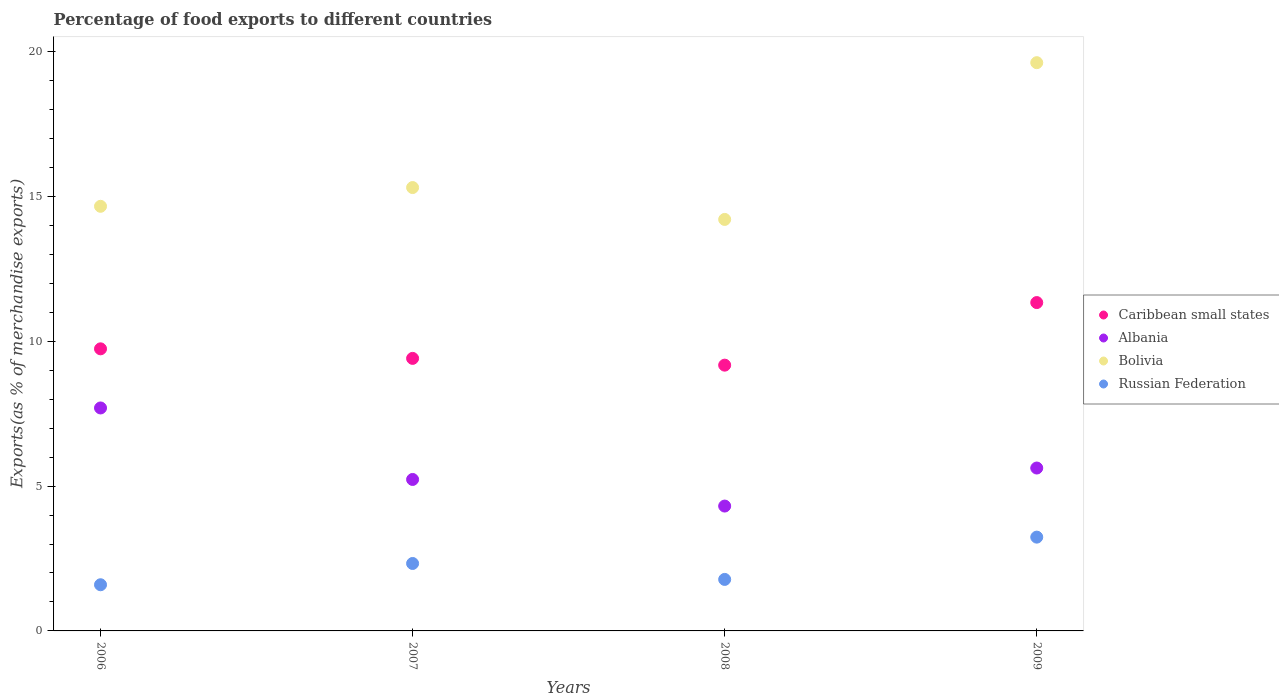How many different coloured dotlines are there?
Your response must be concise. 4. Is the number of dotlines equal to the number of legend labels?
Provide a short and direct response. Yes. What is the percentage of exports to different countries in Albania in 2007?
Provide a succinct answer. 5.23. Across all years, what is the maximum percentage of exports to different countries in Bolivia?
Your answer should be compact. 19.62. Across all years, what is the minimum percentage of exports to different countries in Russian Federation?
Make the answer very short. 1.59. What is the total percentage of exports to different countries in Russian Federation in the graph?
Make the answer very short. 8.94. What is the difference between the percentage of exports to different countries in Caribbean small states in 2007 and that in 2008?
Your answer should be very brief. 0.23. What is the difference between the percentage of exports to different countries in Caribbean small states in 2009 and the percentage of exports to different countries in Bolivia in 2007?
Provide a succinct answer. -3.97. What is the average percentage of exports to different countries in Bolivia per year?
Offer a very short reply. 15.95. In the year 2007, what is the difference between the percentage of exports to different countries in Bolivia and percentage of exports to different countries in Albania?
Your response must be concise. 10.08. What is the ratio of the percentage of exports to different countries in Bolivia in 2006 to that in 2009?
Provide a succinct answer. 0.75. Is the percentage of exports to different countries in Bolivia in 2006 less than that in 2009?
Your answer should be very brief. Yes. What is the difference between the highest and the second highest percentage of exports to different countries in Bolivia?
Provide a short and direct response. 4.31. What is the difference between the highest and the lowest percentage of exports to different countries in Albania?
Keep it short and to the point. 3.39. Is the sum of the percentage of exports to different countries in Caribbean small states in 2008 and 2009 greater than the maximum percentage of exports to different countries in Bolivia across all years?
Ensure brevity in your answer.  Yes. Is it the case that in every year, the sum of the percentage of exports to different countries in Caribbean small states and percentage of exports to different countries in Albania  is greater than the sum of percentage of exports to different countries in Russian Federation and percentage of exports to different countries in Bolivia?
Keep it short and to the point. Yes. Is the percentage of exports to different countries in Albania strictly greater than the percentage of exports to different countries in Caribbean small states over the years?
Provide a short and direct response. No. What is the difference between two consecutive major ticks on the Y-axis?
Make the answer very short. 5. Does the graph contain grids?
Your answer should be compact. No. Where does the legend appear in the graph?
Offer a very short reply. Center right. What is the title of the graph?
Ensure brevity in your answer.  Percentage of food exports to different countries. Does "Latin America(all income levels)" appear as one of the legend labels in the graph?
Make the answer very short. No. What is the label or title of the Y-axis?
Offer a very short reply. Exports(as % of merchandise exports). What is the Exports(as % of merchandise exports) in Caribbean small states in 2006?
Make the answer very short. 9.74. What is the Exports(as % of merchandise exports) of Albania in 2006?
Provide a succinct answer. 7.7. What is the Exports(as % of merchandise exports) of Bolivia in 2006?
Give a very brief answer. 14.66. What is the Exports(as % of merchandise exports) of Russian Federation in 2006?
Make the answer very short. 1.59. What is the Exports(as % of merchandise exports) of Caribbean small states in 2007?
Keep it short and to the point. 9.41. What is the Exports(as % of merchandise exports) of Albania in 2007?
Your response must be concise. 5.23. What is the Exports(as % of merchandise exports) in Bolivia in 2007?
Give a very brief answer. 15.31. What is the Exports(as % of merchandise exports) in Russian Federation in 2007?
Provide a succinct answer. 2.33. What is the Exports(as % of merchandise exports) of Caribbean small states in 2008?
Offer a very short reply. 9.18. What is the Exports(as % of merchandise exports) of Albania in 2008?
Keep it short and to the point. 4.31. What is the Exports(as % of merchandise exports) in Bolivia in 2008?
Your answer should be very brief. 14.21. What is the Exports(as % of merchandise exports) in Russian Federation in 2008?
Offer a terse response. 1.78. What is the Exports(as % of merchandise exports) in Caribbean small states in 2009?
Make the answer very short. 11.34. What is the Exports(as % of merchandise exports) of Albania in 2009?
Offer a very short reply. 5.62. What is the Exports(as % of merchandise exports) of Bolivia in 2009?
Provide a short and direct response. 19.62. What is the Exports(as % of merchandise exports) of Russian Federation in 2009?
Your answer should be very brief. 3.24. Across all years, what is the maximum Exports(as % of merchandise exports) in Caribbean small states?
Provide a succinct answer. 11.34. Across all years, what is the maximum Exports(as % of merchandise exports) in Albania?
Give a very brief answer. 7.7. Across all years, what is the maximum Exports(as % of merchandise exports) in Bolivia?
Keep it short and to the point. 19.62. Across all years, what is the maximum Exports(as % of merchandise exports) in Russian Federation?
Your answer should be compact. 3.24. Across all years, what is the minimum Exports(as % of merchandise exports) of Caribbean small states?
Provide a short and direct response. 9.18. Across all years, what is the minimum Exports(as % of merchandise exports) in Albania?
Your response must be concise. 4.31. Across all years, what is the minimum Exports(as % of merchandise exports) in Bolivia?
Offer a very short reply. 14.21. Across all years, what is the minimum Exports(as % of merchandise exports) of Russian Federation?
Offer a very short reply. 1.59. What is the total Exports(as % of merchandise exports) in Caribbean small states in the graph?
Provide a short and direct response. 39.66. What is the total Exports(as % of merchandise exports) in Albania in the graph?
Your answer should be very brief. 22.86. What is the total Exports(as % of merchandise exports) of Bolivia in the graph?
Provide a succinct answer. 63.8. What is the total Exports(as % of merchandise exports) of Russian Federation in the graph?
Your answer should be very brief. 8.94. What is the difference between the Exports(as % of merchandise exports) of Caribbean small states in 2006 and that in 2007?
Provide a succinct answer. 0.33. What is the difference between the Exports(as % of merchandise exports) of Albania in 2006 and that in 2007?
Keep it short and to the point. 2.47. What is the difference between the Exports(as % of merchandise exports) in Bolivia in 2006 and that in 2007?
Your answer should be very brief. -0.65. What is the difference between the Exports(as % of merchandise exports) in Russian Federation in 2006 and that in 2007?
Ensure brevity in your answer.  -0.73. What is the difference between the Exports(as % of merchandise exports) in Caribbean small states in 2006 and that in 2008?
Provide a succinct answer. 0.56. What is the difference between the Exports(as % of merchandise exports) in Albania in 2006 and that in 2008?
Give a very brief answer. 3.39. What is the difference between the Exports(as % of merchandise exports) in Bolivia in 2006 and that in 2008?
Make the answer very short. 0.45. What is the difference between the Exports(as % of merchandise exports) of Russian Federation in 2006 and that in 2008?
Offer a very short reply. -0.18. What is the difference between the Exports(as % of merchandise exports) in Caribbean small states in 2006 and that in 2009?
Provide a succinct answer. -1.6. What is the difference between the Exports(as % of merchandise exports) in Albania in 2006 and that in 2009?
Your answer should be compact. 2.07. What is the difference between the Exports(as % of merchandise exports) in Bolivia in 2006 and that in 2009?
Provide a short and direct response. -4.96. What is the difference between the Exports(as % of merchandise exports) of Russian Federation in 2006 and that in 2009?
Provide a short and direct response. -1.64. What is the difference between the Exports(as % of merchandise exports) in Caribbean small states in 2007 and that in 2008?
Make the answer very short. 0.23. What is the difference between the Exports(as % of merchandise exports) in Albania in 2007 and that in 2008?
Provide a short and direct response. 0.92. What is the difference between the Exports(as % of merchandise exports) of Bolivia in 2007 and that in 2008?
Your response must be concise. 1.1. What is the difference between the Exports(as % of merchandise exports) in Russian Federation in 2007 and that in 2008?
Give a very brief answer. 0.55. What is the difference between the Exports(as % of merchandise exports) of Caribbean small states in 2007 and that in 2009?
Provide a succinct answer. -1.93. What is the difference between the Exports(as % of merchandise exports) of Albania in 2007 and that in 2009?
Your answer should be very brief. -0.39. What is the difference between the Exports(as % of merchandise exports) of Bolivia in 2007 and that in 2009?
Ensure brevity in your answer.  -4.31. What is the difference between the Exports(as % of merchandise exports) of Russian Federation in 2007 and that in 2009?
Give a very brief answer. -0.91. What is the difference between the Exports(as % of merchandise exports) in Caribbean small states in 2008 and that in 2009?
Make the answer very short. -2.16. What is the difference between the Exports(as % of merchandise exports) in Albania in 2008 and that in 2009?
Give a very brief answer. -1.31. What is the difference between the Exports(as % of merchandise exports) in Bolivia in 2008 and that in 2009?
Your answer should be compact. -5.41. What is the difference between the Exports(as % of merchandise exports) of Russian Federation in 2008 and that in 2009?
Your response must be concise. -1.46. What is the difference between the Exports(as % of merchandise exports) in Caribbean small states in 2006 and the Exports(as % of merchandise exports) in Albania in 2007?
Keep it short and to the point. 4.51. What is the difference between the Exports(as % of merchandise exports) in Caribbean small states in 2006 and the Exports(as % of merchandise exports) in Bolivia in 2007?
Provide a short and direct response. -5.57. What is the difference between the Exports(as % of merchandise exports) of Caribbean small states in 2006 and the Exports(as % of merchandise exports) of Russian Federation in 2007?
Give a very brief answer. 7.41. What is the difference between the Exports(as % of merchandise exports) of Albania in 2006 and the Exports(as % of merchandise exports) of Bolivia in 2007?
Your answer should be very brief. -7.61. What is the difference between the Exports(as % of merchandise exports) of Albania in 2006 and the Exports(as % of merchandise exports) of Russian Federation in 2007?
Make the answer very short. 5.37. What is the difference between the Exports(as % of merchandise exports) of Bolivia in 2006 and the Exports(as % of merchandise exports) of Russian Federation in 2007?
Ensure brevity in your answer.  12.33. What is the difference between the Exports(as % of merchandise exports) of Caribbean small states in 2006 and the Exports(as % of merchandise exports) of Albania in 2008?
Keep it short and to the point. 5.43. What is the difference between the Exports(as % of merchandise exports) in Caribbean small states in 2006 and the Exports(as % of merchandise exports) in Bolivia in 2008?
Offer a terse response. -4.47. What is the difference between the Exports(as % of merchandise exports) of Caribbean small states in 2006 and the Exports(as % of merchandise exports) of Russian Federation in 2008?
Provide a short and direct response. 7.96. What is the difference between the Exports(as % of merchandise exports) of Albania in 2006 and the Exports(as % of merchandise exports) of Bolivia in 2008?
Offer a very short reply. -6.51. What is the difference between the Exports(as % of merchandise exports) of Albania in 2006 and the Exports(as % of merchandise exports) of Russian Federation in 2008?
Provide a succinct answer. 5.92. What is the difference between the Exports(as % of merchandise exports) in Bolivia in 2006 and the Exports(as % of merchandise exports) in Russian Federation in 2008?
Ensure brevity in your answer.  12.88. What is the difference between the Exports(as % of merchandise exports) in Caribbean small states in 2006 and the Exports(as % of merchandise exports) in Albania in 2009?
Keep it short and to the point. 4.12. What is the difference between the Exports(as % of merchandise exports) in Caribbean small states in 2006 and the Exports(as % of merchandise exports) in Bolivia in 2009?
Offer a very short reply. -9.88. What is the difference between the Exports(as % of merchandise exports) of Caribbean small states in 2006 and the Exports(as % of merchandise exports) of Russian Federation in 2009?
Ensure brevity in your answer.  6.5. What is the difference between the Exports(as % of merchandise exports) of Albania in 2006 and the Exports(as % of merchandise exports) of Bolivia in 2009?
Your answer should be compact. -11.92. What is the difference between the Exports(as % of merchandise exports) of Albania in 2006 and the Exports(as % of merchandise exports) of Russian Federation in 2009?
Provide a short and direct response. 4.46. What is the difference between the Exports(as % of merchandise exports) in Bolivia in 2006 and the Exports(as % of merchandise exports) in Russian Federation in 2009?
Your answer should be very brief. 11.42. What is the difference between the Exports(as % of merchandise exports) in Caribbean small states in 2007 and the Exports(as % of merchandise exports) in Albania in 2008?
Your response must be concise. 5.1. What is the difference between the Exports(as % of merchandise exports) in Caribbean small states in 2007 and the Exports(as % of merchandise exports) in Bolivia in 2008?
Keep it short and to the point. -4.8. What is the difference between the Exports(as % of merchandise exports) in Caribbean small states in 2007 and the Exports(as % of merchandise exports) in Russian Federation in 2008?
Ensure brevity in your answer.  7.63. What is the difference between the Exports(as % of merchandise exports) in Albania in 2007 and the Exports(as % of merchandise exports) in Bolivia in 2008?
Your answer should be compact. -8.98. What is the difference between the Exports(as % of merchandise exports) of Albania in 2007 and the Exports(as % of merchandise exports) of Russian Federation in 2008?
Your answer should be very brief. 3.45. What is the difference between the Exports(as % of merchandise exports) in Bolivia in 2007 and the Exports(as % of merchandise exports) in Russian Federation in 2008?
Ensure brevity in your answer.  13.53. What is the difference between the Exports(as % of merchandise exports) of Caribbean small states in 2007 and the Exports(as % of merchandise exports) of Albania in 2009?
Give a very brief answer. 3.79. What is the difference between the Exports(as % of merchandise exports) of Caribbean small states in 2007 and the Exports(as % of merchandise exports) of Bolivia in 2009?
Offer a very short reply. -10.21. What is the difference between the Exports(as % of merchandise exports) in Caribbean small states in 2007 and the Exports(as % of merchandise exports) in Russian Federation in 2009?
Your response must be concise. 6.17. What is the difference between the Exports(as % of merchandise exports) in Albania in 2007 and the Exports(as % of merchandise exports) in Bolivia in 2009?
Your response must be concise. -14.39. What is the difference between the Exports(as % of merchandise exports) in Albania in 2007 and the Exports(as % of merchandise exports) in Russian Federation in 2009?
Make the answer very short. 1.99. What is the difference between the Exports(as % of merchandise exports) in Bolivia in 2007 and the Exports(as % of merchandise exports) in Russian Federation in 2009?
Give a very brief answer. 12.07. What is the difference between the Exports(as % of merchandise exports) of Caribbean small states in 2008 and the Exports(as % of merchandise exports) of Albania in 2009?
Give a very brief answer. 3.55. What is the difference between the Exports(as % of merchandise exports) in Caribbean small states in 2008 and the Exports(as % of merchandise exports) in Bolivia in 2009?
Ensure brevity in your answer.  -10.44. What is the difference between the Exports(as % of merchandise exports) in Caribbean small states in 2008 and the Exports(as % of merchandise exports) in Russian Federation in 2009?
Your answer should be very brief. 5.94. What is the difference between the Exports(as % of merchandise exports) in Albania in 2008 and the Exports(as % of merchandise exports) in Bolivia in 2009?
Your answer should be very brief. -15.31. What is the difference between the Exports(as % of merchandise exports) in Albania in 2008 and the Exports(as % of merchandise exports) in Russian Federation in 2009?
Keep it short and to the point. 1.07. What is the difference between the Exports(as % of merchandise exports) of Bolivia in 2008 and the Exports(as % of merchandise exports) of Russian Federation in 2009?
Offer a very short reply. 10.97. What is the average Exports(as % of merchandise exports) in Caribbean small states per year?
Your response must be concise. 9.92. What is the average Exports(as % of merchandise exports) of Albania per year?
Give a very brief answer. 5.72. What is the average Exports(as % of merchandise exports) in Bolivia per year?
Make the answer very short. 15.95. What is the average Exports(as % of merchandise exports) of Russian Federation per year?
Offer a very short reply. 2.23. In the year 2006, what is the difference between the Exports(as % of merchandise exports) in Caribbean small states and Exports(as % of merchandise exports) in Albania?
Offer a terse response. 2.04. In the year 2006, what is the difference between the Exports(as % of merchandise exports) of Caribbean small states and Exports(as % of merchandise exports) of Bolivia?
Offer a very short reply. -4.92. In the year 2006, what is the difference between the Exports(as % of merchandise exports) of Caribbean small states and Exports(as % of merchandise exports) of Russian Federation?
Provide a short and direct response. 8.15. In the year 2006, what is the difference between the Exports(as % of merchandise exports) of Albania and Exports(as % of merchandise exports) of Bolivia?
Your answer should be very brief. -6.96. In the year 2006, what is the difference between the Exports(as % of merchandise exports) in Albania and Exports(as % of merchandise exports) in Russian Federation?
Your response must be concise. 6.1. In the year 2006, what is the difference between the Exports(as % of merchandise exports) in Bolivia and Exports(as % of merchandise exports) in Russian Federation?
Offer a terse response. 13.07. In the year 2007, what is the difference between the Exports(as % of merchandise exports) in Caribbean small states and Exports(as % of merchandise exports) in Albania?
Provide a short and direct response. 4.18. In the year 2007, what is the difference between the Exports(as % of merchandise exports) in Caribbean small states and Exports(as % of merchandise exports) in Bolivia?
Your response must be concise. -5.9. In the year 2007, what is the difference between the Exports(as % of merchandise exports) in Caribbean small states and Exports(as % of merchandise exports) in Russian Federation?
Your answer should be very brief. 7.08. In the year 2007, what is the difference between the Exports(as % of merchandise exports) of Albania and Exports(as % of merchandise exports) of Bolivia?
Your answer should be compact. -10.08. In the year 2007, what is the difference between the Exports(as % of merchandise exports) in Albania and Exports(as % of merchandise exports) in Russian Federation?
Keep it short and to the point. 2.9. In the year 2007, what is the difference between the Exports(as % of merchandise exports) in Bolivia and Exports(as % of merchandise exports) in Russian Federation?
Give a very brief answer. 12.98. In the year 2008, what is the difference between the Exports(as % of merchandise exports) in Caribbean small states and Exports(as % of merchandise exports) in Albania?
Provide a short and direct response. 4.87. In the year 2008, what is the difference between the Exports(as % of merchandise exports) of Caribbean small states and Exports(as % of merchandise exports) of Bolivia?
Make the answer very short. -5.03. In the year 2008, what is the difference between the Exports(as % of merchandise exports) of Caribbean small states and Exports(as % of merchandise exports) of Russian Federation?
Provide a short and direct response. 7.4. In the year 2008, what is the difference between the Exports(as % of merchandise exports) of Albania and Exports(as % of merchandise exports) of Bolivia?
Give a very brief answer. -9.9. In the year 2008, what is the difference between the Exports(as % of merchandise exports) of Albania and Exports(as % of merchandise exports) of Russian Federation?
Your answer should be very brief. 2.53. In the year 2008, what is the difference between the Exports(as % of merchandise exports) of Bolivia and Exports(as % of merchandise exports) of Russian Federation?
Make the answer very short. 12.43. In the year 2009, what is the difference between the Exports(as % of merchandise exports) of Caribbean small states and Exports(as % of merchandise exports) of Albania?
Offer a terse response. 5.71. In the year 2009, what is the difference between the Exports(as % of merchandise exports) of Caribbean small states and Exports(as % of merchandise exports) of Bolivia?
Offer a very short reply. -8.28. In the year 2009, what is the difference between the Exports(as % of merchandise exports) in Caribbean small states and Exports(as % of merchandise exports) in Russian Federation?
Offer a very short reply. 8.1. In the year 2009, what is the difference between the Exports(as % of merchandise exports) of Albania and Exports(as % of merchandise exports) of Bolivia?
Make the answer very short. -14. In the year 2009, what is the difference between the Exports(as % of merchandise exports) of Albania and Exports(as % of merchandise exports) of Russian Federation?
Your answer should be very brief. 2.39. In the year 2009, what is the difference between the Exports(as % of merchandise exports) of Bolivia and Exports(as % of merchandise exports) of Russian Federation?
Ensure brevity in your answer.  16.38. What is the ratio of the Exports(as % of merchandise exports) of Caribbean small states in 2006 to that in 2007?
Give a very brief answer. 1.04. What is the ratio of the Exports(as % of merchandise exports) in Albania in 2006 to that in 2007?
Ensure brevity in your answer.  1.47. What is the ratio of the Exports(as % of merchandise exports) of Bolivia in 2006 to that in 2007?
Ensure brevity in your answer.  0.96. What is the ratio of the Exports(as % of merchandise exports) of Russian Federation in 2006 to that in 2007?
Your response must be concise. 0.68. What is the ratio of the Exports(as % of merchandise exports) of Caribbean small states in 2006 to that in 2008?
Ensure brevity in your answer.  1.06. What is the ratio of the Exports(as % of merchandise exports) in Albania in 2006 to that in 2008?
Give a very brief answer. 1.79. What is the ratio of the Exports(as % of merchandise exports) in Bolivia in 2006 to that in 2008?
Your answer should be compact. 1.03. What is the ratio of the Exports(as % of merchandise exports) of Russian Federation in 2006 to that in 2008?
Your response must be concise. 0.9. What is the ratio of the Exports(as % of merchandise exports) in Caribbean small states in 2006 to that in 2009?
Your answer should be very brief. 0.86. What is the ratio of the Exports(as % of merchandise exports) in Albania in 2006 to that in 2009?
Keep it short and to the point. 1.37. What is the ratio of the Exports(as % of merchandise exports) of Bolivia in 2006 to that in 2009?
Provide a succinct answer. 0.75. What is the ratio of the Exports(as % of merchandise exports) in Russian Federation in 2006 to that in 2009?
Provide a short and direct response. 0.49. What is the ratio of the Exports(as % of merchandise exports) in Caribbean small states in 2007 to that in 2008?
Offer a terse response. 1.03. What is the ratio of the Exports(as % of merchandise exports) in Albania in 2007 to that in 2008?
Keep it short and to the point. 1.21. What is the ratio of the Exports(as % of merchandise exports) of Bolivia in 2007 to that in 2008?
Keep it short and to the point. 1.08. What is the ratio of the Exports(as % of merchandise exports) in Russian Federation in 2007 to that in 2008?
Your answer should be very brief. 1.31. What is the ratio of the Exports(as % of merchandise exports) in Caribbean small states in 2007 to that in 2009?
Your answer should be very brief. 0.83. What is the ratio of the Exports(as % of merchandise exports) in Albania in 2007 to that in 2009?
Make the answer very short. 0.93. What is the ratio of the Exports(as % of merchandise exports) in Bolivia in 2007 to that in 2009?
Give a very brief answer. 0.78. What is the ratio of the Exports(as % of merchandise exports) of Russian Federation in 2007 to that in 2009?
Make the answer very short. 0.72. What is the ratio of the Exports(as % of merchandise exports) in Caribbean small states in 2008 to that in 2009?
Your response must be concise. 0.81. What is the ratio of the Exports(as % of merchandise exports) of Albania in 2008 to that in 2009?
Offer a very short reply. 0.77. What is the ratio of the Exports(as % of merchandise exports) in Bolivia in 2008 to that in 2009?
Offer a terse response. 0.72. What is the ratio of the Exports(as % of merchandise exports) of Russian Federation in 2008 to that in 2009?
Offer a very short reply. 0.55. What is the difference between the highest and the second highest Exports(as % of merchandise exports) of Caribbean small states?
Your response must be concise. 1.6. What is the difference between the highest and the second highest Exports(as % of merchandise exports) in Albania?
Offer a very short reply. 2.07. What is the difference between the highest and the second highest Exports(as % of merchandise exports) in Bolivia?
Keep it short and to the point. 4.31. What is the difference between the highest and the second highest Exports(as % of merchandise exports) of Russian Federation?
Give a very brief answer. 0.91. What is the difference between the highest and the lowest Exports(as % of merchandise exports) of Caribbean small states?
Your response must be concise. 2.16. What is the difference between the highest and the lowest Exports(as % of merchandise exports) in Albania?
Your answer should be very brief. 3.39. What is the difference between the highest and the lowest Exports(as % of merchandise exports) in Bolivia?
Offer a terse response. 5.41. What is the difference between the highest and the lowest Exports(as % of merchandise exports) of Russian Federation?
Provide a short and direct response. 1.64. 